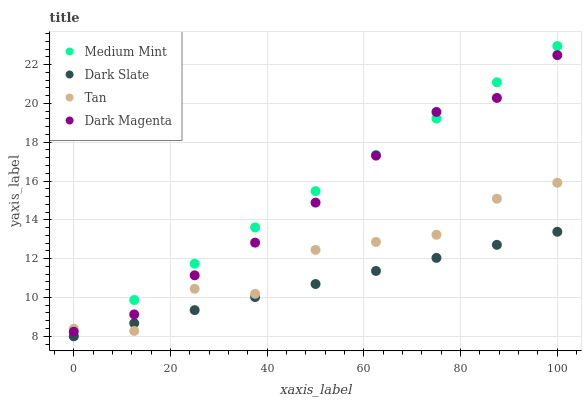Does Dark Slate have the minimum area under the curve?
Answer yes or no. Yes. Does Medium Mint have the maximum area under the curve?
Answer yes or no. Yes. Does Tan have the minimum area under the curve?
Answer yes or no. No. Does Tan have the maximum area under the curve?
Answer yes or no. No. Is Dark Slate the smoothest?
Answer yes or no. Yes. Is Tan the roughest?
Answer yes or no. Yes. Is Tan the smoothest?
Answer yes or no. No. Is Dark Slate the roughest?
Answer yes or no. No. Does Medium Mint have the lowest value?
Answer yes or no. Yes. Does Tan have the lowest value?
Answer yes or no. No. Does Medium Mint have the highest value?
Answer yes or no. Yes. Does Tan have the highest value?
Answer yes or no. No. Is Dark Slate less than Dark Magenta?
Answer yes or no. Yes. Is Dark Magenta greater than Dark Slate?
Answer yes or no. Yes. Does Medium Mint intersect Tan?
Answer yes or no. Yes. Is Medium Mint less than Tan?
Answer yes or no. No. Is Medium Mint greater than Tan?
Answer yes or no. No. Does Dark Slate intersect Dark Magenta?
Answer yes or no. No. 